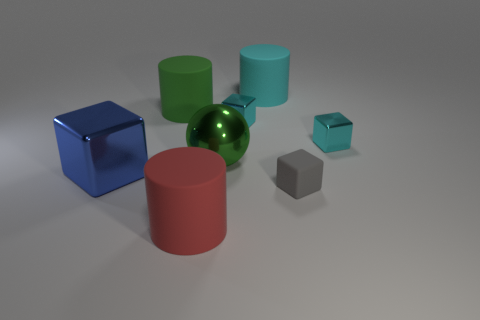How many green spheres are left of the gray matte thing that is in front of the small cyan shiny block that is on the right side of the small gray block?
Ensure brevity in your answer.  1. How many shiny objects are left of the green metal object?
Ensure brevity in your answer.  1. There is a rubber cylinder that is on the left side of the big rubber object in front of the large cube; what color is it?
Offer a very short reply. Green. Are there the same number of green rubber things that are behind the cyan cylinder and large blue metal balls?
Offer a very short reply. Yes. The red object that is in front of the big thing that is right of the small shiny thing that is on the left side of the large cyan cylinder is made of what material?
Your answer should be compact. Rubber. The metallic block that is on the left side of the large metal ball is what color?
Make the answer very short. Blue. Is there any other thing that is the same shape as the big green shiny object?
Make the answer very short. No. There is a gray object behind the big thing in front of the large blue metal block; what is its size?
Your response must be concise. Small. Are there the same number of big blue metallic cubes in front of the large cube and big matte cylinders that are in front of the gray cube?
Offer a terse response. No. There is a large thing that is the same material as the sphere; what color is it?
Provide a succinct answer. Blue. 